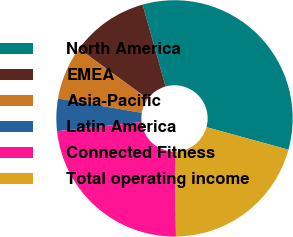Convert chart. <chart><loc_0><loc_0><loc_500><loc_500><pie_chart><fcel>North America<fcel>EMEA<fcel>Asia-Pacific<fcel>Latin America<fcel>Connected Fitness<fcel>Total operating income<nl><fcel>33.61%<fcel>10.63%<fcel>7.34%<fcel>4.42%<fcel>23.46%<fcel>20.54%<nl></chart> 